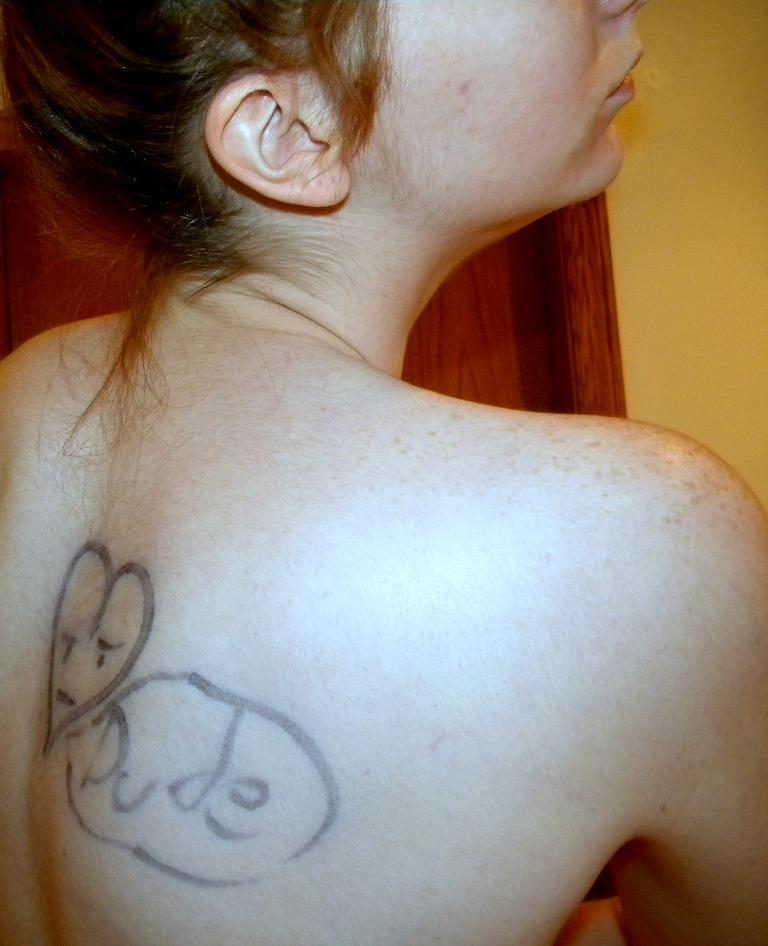Who is present in the image? There is a woman in the image. How is the woman depicted in the image? The woman is truncated in the image. What can be seen in the background of the image? There is a wall in the background of the image. What type of grape is the woman holding in the image? There is no grape present in the image; the woman is truncated and no objects are visible in her hand. 